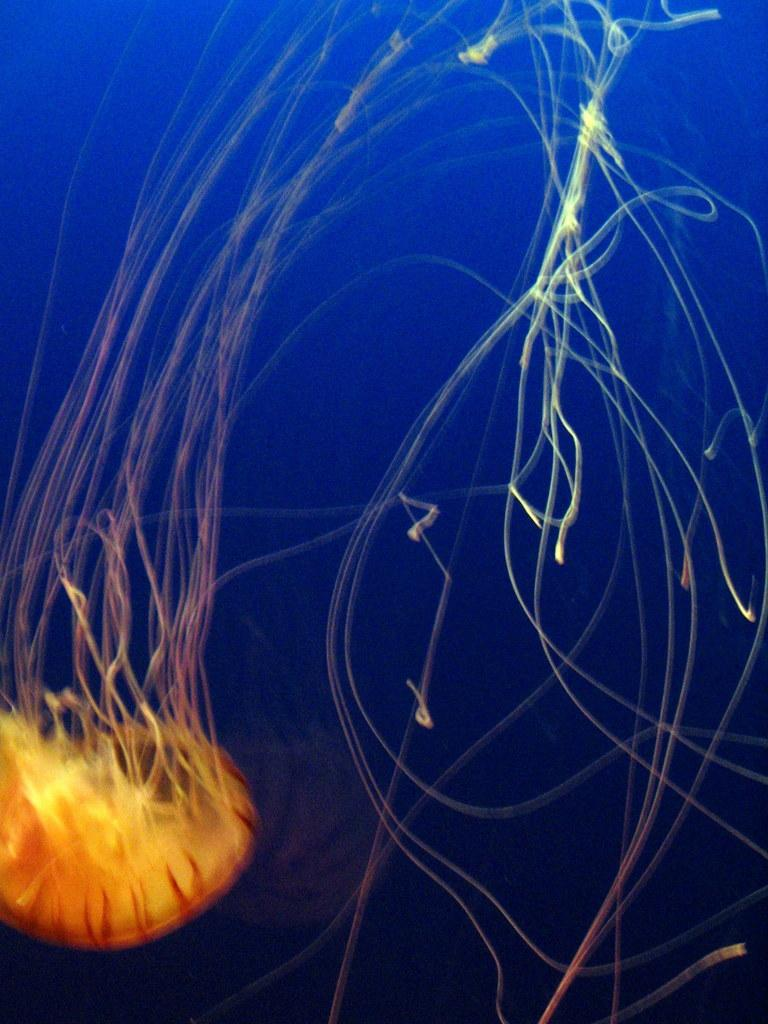What type of animal can be seen in the image? There is an aquatic animal animal in the image. What color is the background of the image? The background of the image is blue. What is the price of the route mentioned in the image? There is no mention of a price or route in the image, as it only features an aquatic animal and a blue background. 